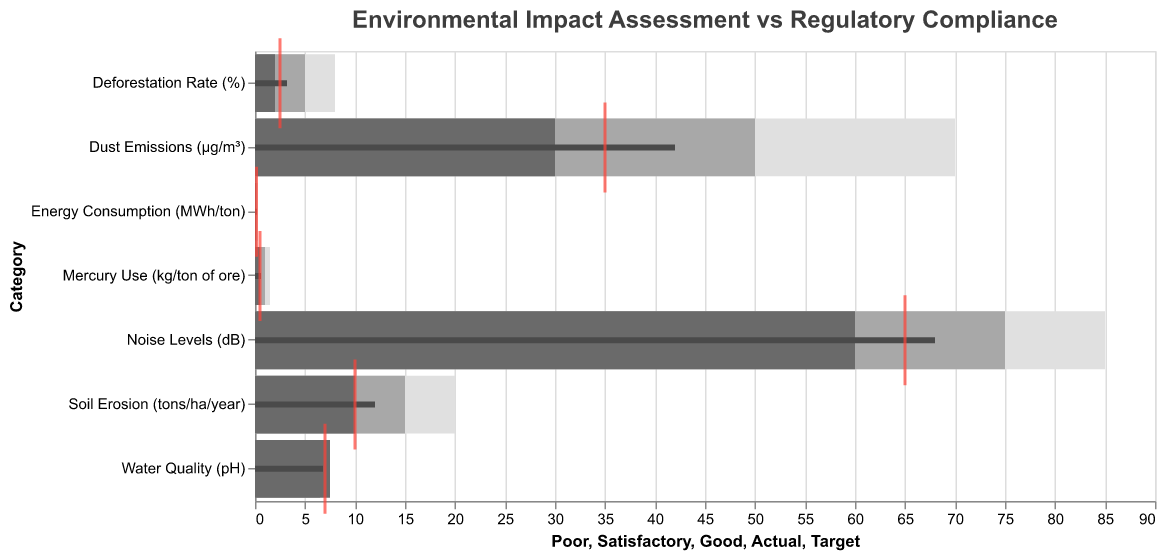What's the title of the figure? The title is usually placed at the top of the figure for identification. Here, the title is written in the code under the "title" field.
Answer: Environmental Impact Assessment vs Regulatory Compliance What's the target value for Mercury Use (kg/ton of ore)? The target value is denoted by a red tick mark for each category in the Bullet Chart. From the data, the target for Mercury Use is written in the "Target" field.
Answer: 0.5 Which category has the highest actual value? To find the highest actual value, compare the actual values for each category noted by the dark bar in each bullet chart. The highest of these values is the value for Noise Levels.
Answer: Noise Levels For which categories are the actual values below satisfactory? Categories with actual values below the satisfactory range can be identified by comparing the actual value markers to the satisfactory thresholds in light grey. These include Water Quality, Soil Erosion, Dust Emissions, Noise Levels, and Mercury Use.
Answer: Water Quality, Soil Erosion, Dust Emissions, Noise Levels, Mercury Use Is the actual energy consumption better or worse than the target? Compare the actual value bar for Energy Consumption with the target value tick mark in the bullet chart. The actual value (0.18) is worse than the target (0.15).
Answer: Worse How much higher is the actual Dust Emissions compared to its target value? Subtract the target value from the actual value for Dust Emissions: 42 (actual) - 35 (target) = 7 µg/m³.
Answer: 7 µg/m³ Which category is closest to meeting its target based on actual values? Determine which category's actual value is nearest to its target value by comparing all the differences. Water Quality (pH) has an actual value of 6.8, very close to its target of 7.0, a difference of 0.2.
Answer: Water Quality (pH) Are the actual values within the thresholds for regulatory compliance? Each category's actual value is checked against its specified threshold range. Water Quality, Soil Erosion, Deforestation Rate, Noise Levels, Mercury Use, and Energy Consumption all lie within their respective thresholds. Dust Emissions exceed the threshold.
Answer: No, Dust Emissions exceed the threshold How does the actual value for Deforestation Rate compare to its good benchmark? The good benchmark for Deforestation Rate is 2%. The actual value, marked by the dark gray bar, is 3.2%, which is above the good benchmark.
Answer: Above 